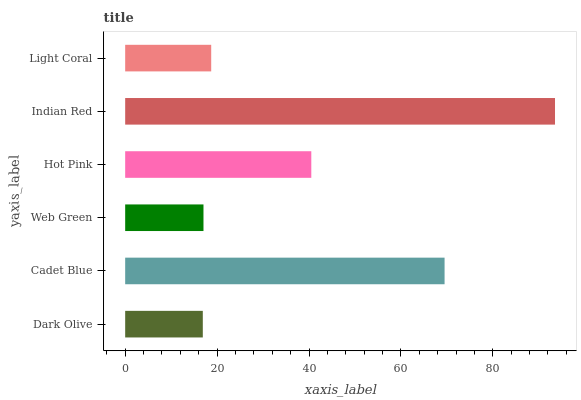Is Dark Olive the minimum?
Answer yes or no. Yes. Is Indian Red the maximum?
Answer yes or no. Yes. Is Cadet Blue the minimum?
Answer yes or no. No. Is Cadet Blue the maximum?
Answer yes or no. No. Is Cadet Blue greater than Dark Olive?
Answer yes or no. Yes. Is Dark Olive less than Cadet Blue?
Answer yes or no. Yes. Is Dark Olive greater than Cadet Blue?
Answer yes or no. No. Is Cadet Blue less than Dark Olive?
Answer yes or no. No. Is Hot Pink the high median?
Answer yes or no. Yes. Is Light Coral the low median?
Answer yes or no. Yes. Is Light Coral the high median?
Answer yes or no. No. Is Dark Olive the low median?
Answer yes or no. No. 